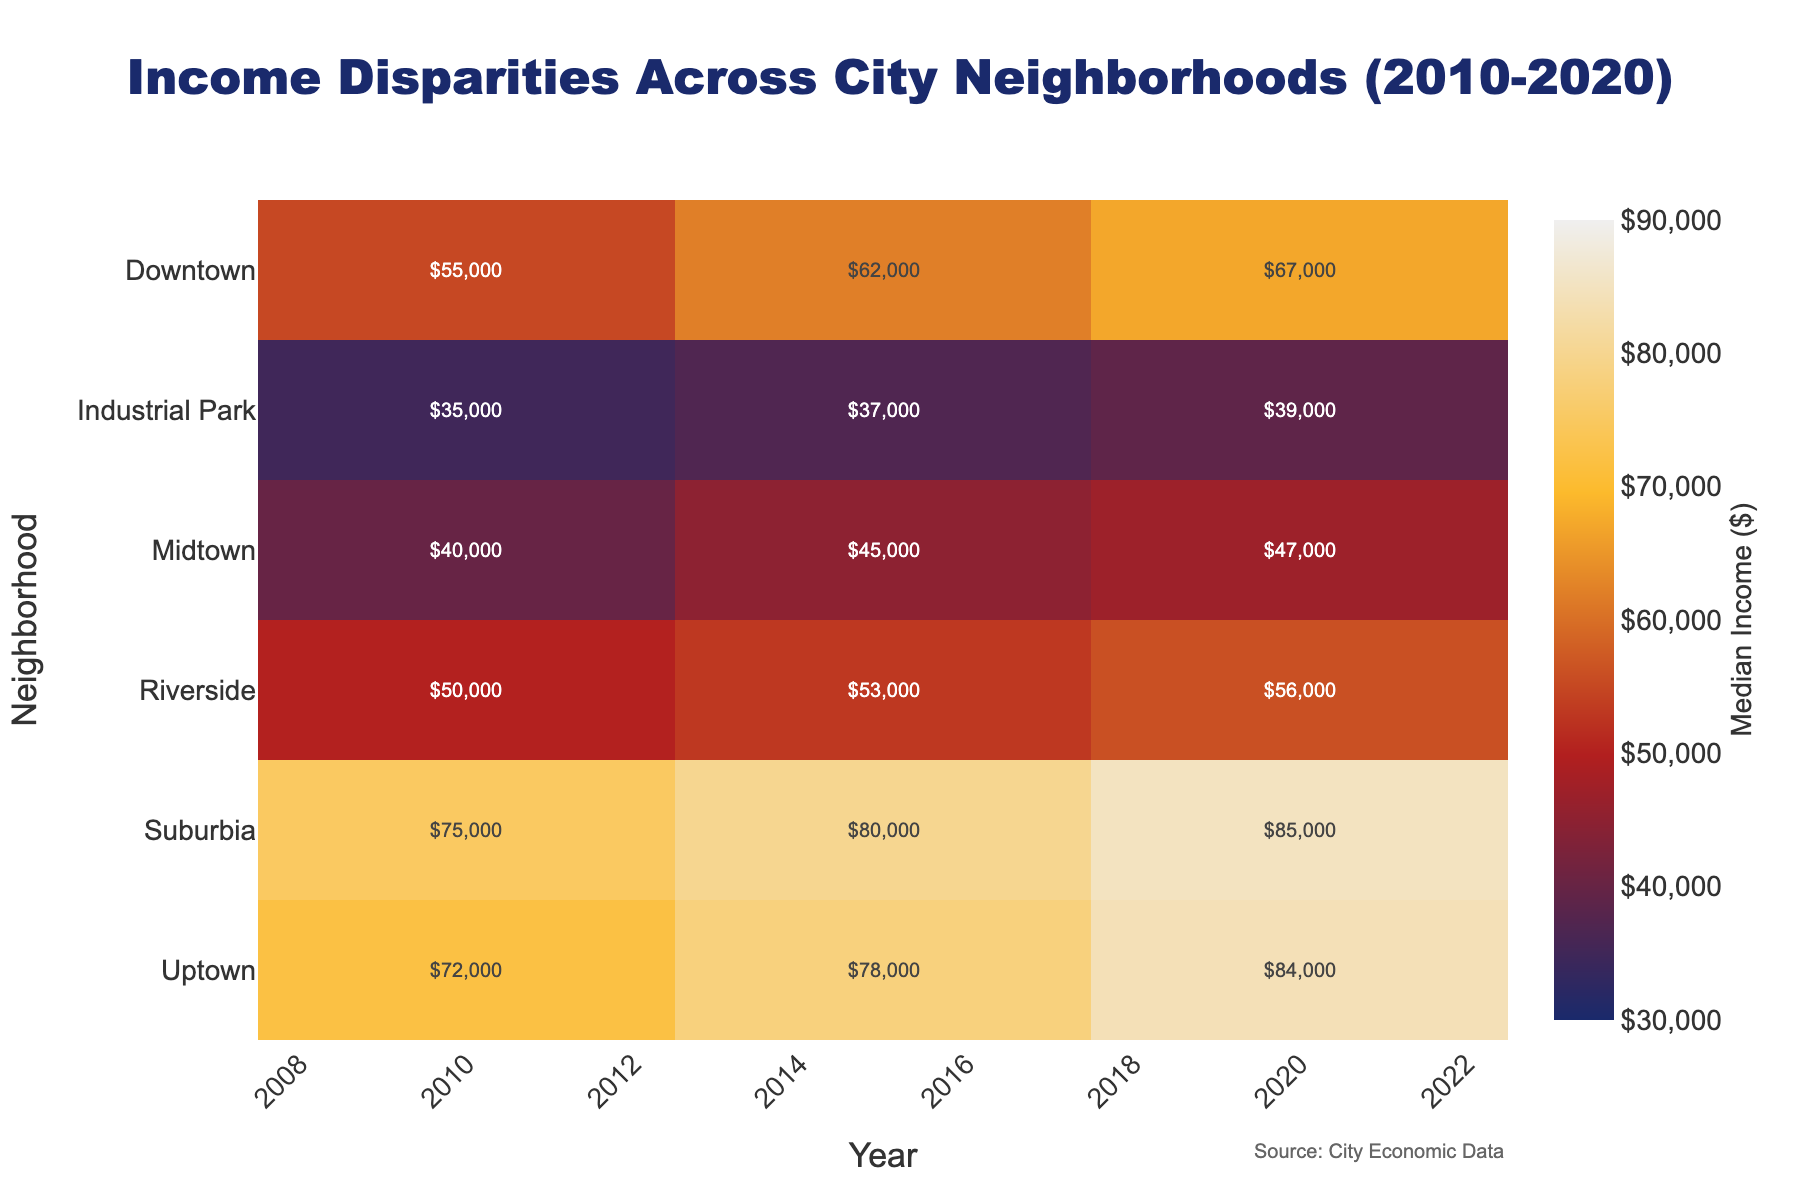what's the title of the heatmap figure? The title can be found at the top of the figure. From the given code, we know that the title is 'Income Disparities Across City Neighborhoods (2010-2020)'.
Answer: Income Disparities Across City Neighborhoods (2010-2020) Which neighborhood had the highest median income in 2010? To answer this, look at the column for the year 2010 and identify the neighborhood with the darkest color or the highest value. The 'Suburbia' neighborhood has the highest value.
Answer: Suburbia How did the median income in Downtown change from 2010 to 2020? Compare the median income in Downtown between 2010 and 2020. In 2010, it was $55,000, and in 2020 it was $67,000. So the change is $67,000 - $55,000.
Answer: $12,000 increase Which neighborhood saw the smallest increase in median income over the decade? Calculate the income gain for each neighborhood from 2010 to 2020 and find the smallest value. 'Midtown' increased from $40,000 to $47,000, which is a $7,000 increase, the smallest among all the neighborhoods.
Answer: Midtown Rank the neighborhoods in ascending order of their median income for the year 2020. To rank them, list each neighborhood's median income for 2020 and sort them: Industrial Park ($39,000), Midtown ($47,000), Riverside ($56,000), Downtown ($67,000), Uptown ($84,000), Suburbia ($85,000).
Answer: Industrial Park, Midtown, Riverside, Downtown, Uptown, Suburbia Which neighborhood had the most consistent median income growth over the years? To determine the most consistent growth, look for a neighborhood where the increase in income appears relatively uniform or linear over the years. 'Suburbia' exhibits a clear, steady growth pattern.
Answer: Suburbia What is the median income difference between Uptown and Downtown in 2015? Look at the median incomes for Uptown and Downtown in 2015. Uptown had $78,000 and Downtown had $62,000. The difference is $78,000 - $62,000.
Answer: $16,000 Which year showed the most significant change in median income for Riverside? Compare the change in Riverside's median income year by year: $50,000 in 2010, $53,000 in 2015, and $56,000 in 2020. The most significant change is from 2010 to 2015, with an increase of $3,000.
Answer: 2010 to 2015 